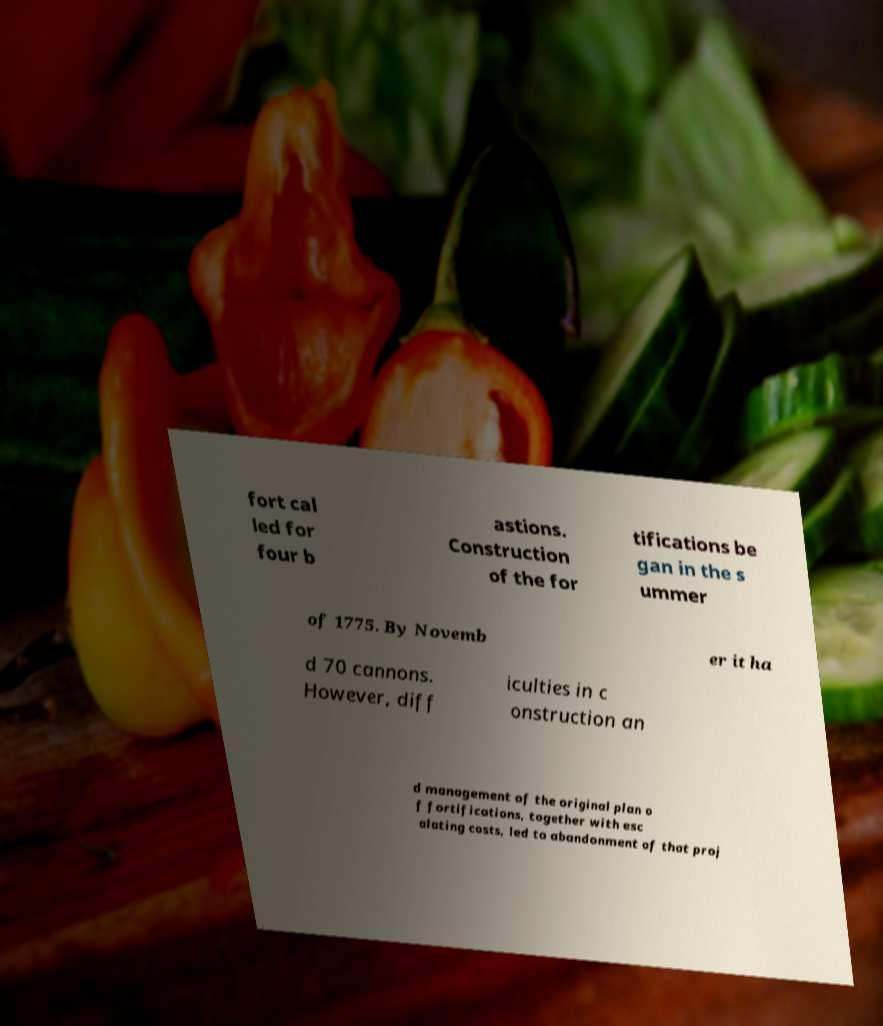For documentation purposes, I need the text within this image transcribed. Could you provide that? fort cal led for four b astions. Construction of the for tifications be gan in the s ummer of 1775. By Novemb er it ha d 70 cannons. However, diff iculties in c onstruction an d management of the original plan o f fortifications, together with esc alating costs, led to abandonment of that proj 